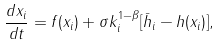Convert formula to latex. <formula><loc_0><loc_0><loc_500><loc_500>\frac { d x _ { i } } { d t } = f ( x _ { i } ) + \sigma k _ { i } ^ { 1 - \beta } [ \bar { h } _ { i } - h ( x _ { i } ) ] ,</formula> 